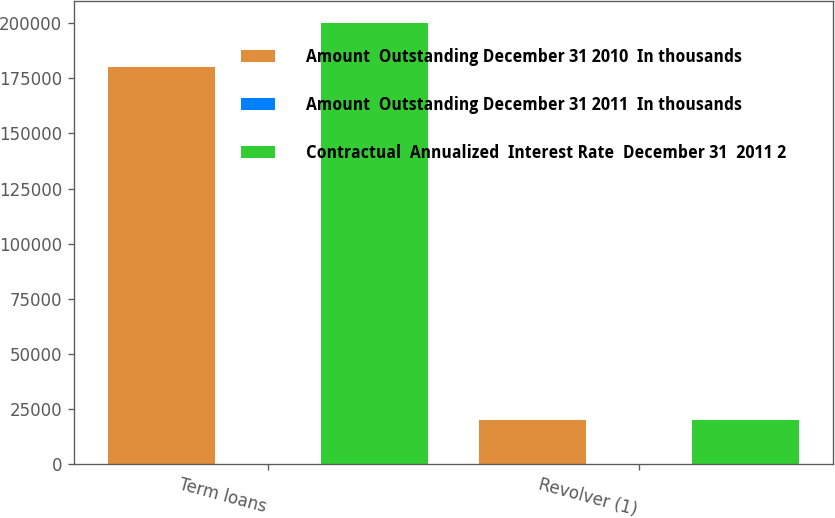Convert chart. <chart><loc_0><loc_0><loc_500><loc_500><stacked_bar_chart><ecel><fcel>Term loans<fcel>Revolver (1)<nl><fcel>Amount  Outstanding December 31 2010  In thousands<fcel>180000<fcel>20000<nl><fcel>Amount  Outstanding December 31 2011  In thousands<fcel>2.08<fcel>2.08<nl><fcel>Contractual  Annualized  Interest Rate  December 31  2011 2<fcel>200000<fcel>20156<nl></chart> 